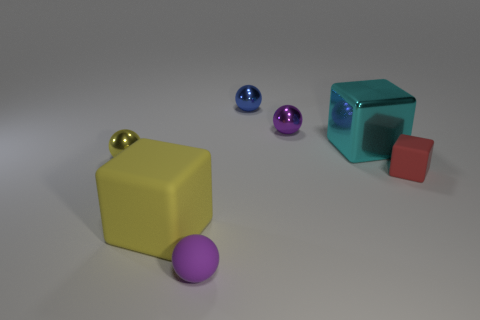What can we infer about the size of the objects relative to each other? From the image, we can infer that there is a range of sizes among the objects. The yellow and cyan cubes appear to be larger than the spheres and the small red cube. The variation in size among similar-shaped objects can give us cues about their relative distances and contribute to the sense of depth in the image. Do you think there's a specific purpose for this arrangement? While the purpose is not immediately clear, the arrangement might be intentional to display the objects' geometrical shapes and how they interact with light, which could be useful for artistic or educational demonstrations about color, form, lighting, and perspective. 